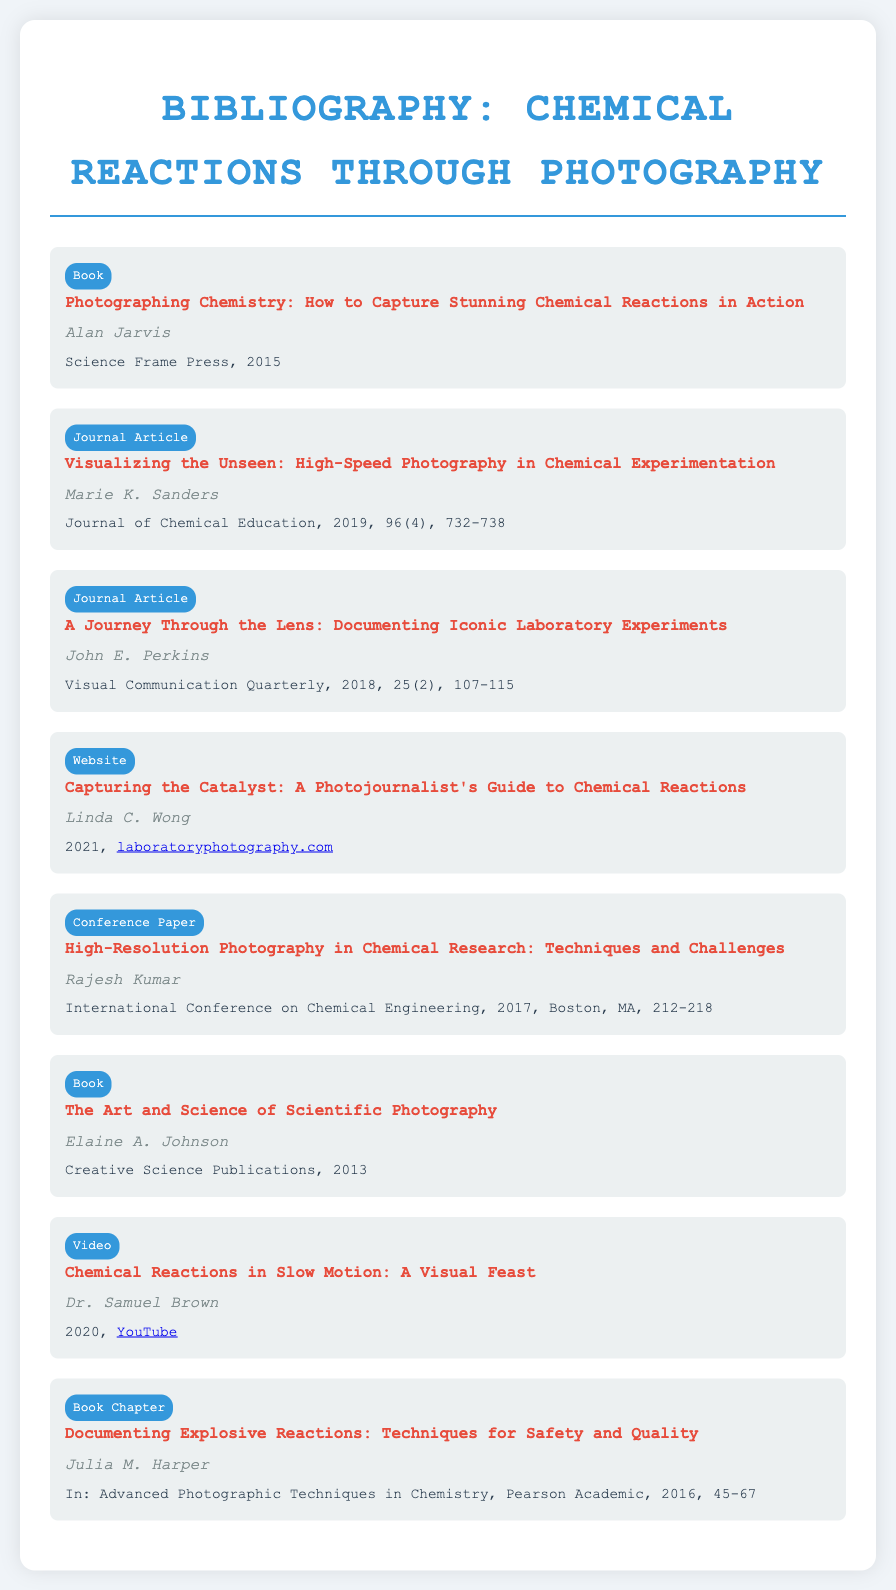What is the title of the book by Alan Jarvis? The title of the book is explicitly mentioned in the entry, which is "Photographing Chemistry: How to Capture Stunning Chemical Reactions in Action."
Answer: Photographing Chemistry: How to Capture Stunning Chemical Reactions in Action Who is the author of the journal article in the Journal of Chemical Education? The author of the journal article titled "Visualizing the Unseen: High-Speed Photography in Chemical Experimentation" is listed in the entry as Marie K. Sanders.
Answer: Marie K. Sanders When was the website "Capturing the Catalyst" published? The publication year for the website by Linda C. Wong is included in the document entry, specified as 2021.
Answer: 2021 What type of document is "High-Resolution Photography in Chemical Research: Techniques and Challenges"? The document entry designates it as a conference paper, which is indicated in its type section.
Answer: Conference Paper In what year was "The Art and Science of Scientific Photography" published? The publication year is straightforwardly given in the entry, which shows it was published in 2013.
Answer: 2013 Which platform has the video "Chemical Reactions in Slow Motion: A Visual Feast"? The entry provides the specific platform, which is YouTube, where the video is available.
Answer: YouTube Who authored the book chapter on documenting explosive reactions? The author of the book chapter titled "Documenting Explosive Reactions: Techniques for Safety and Quality" is stated as Julia M. Harper.
Answer: Julia M. Harper What is the primary focus of Marie K. Sanders' journal article? The title of the article gives insight into its subject matter, which is about visualizing chemical experimentation through high-speed photography.
Answer: High-Speed Photography in Chemical Experimentation 